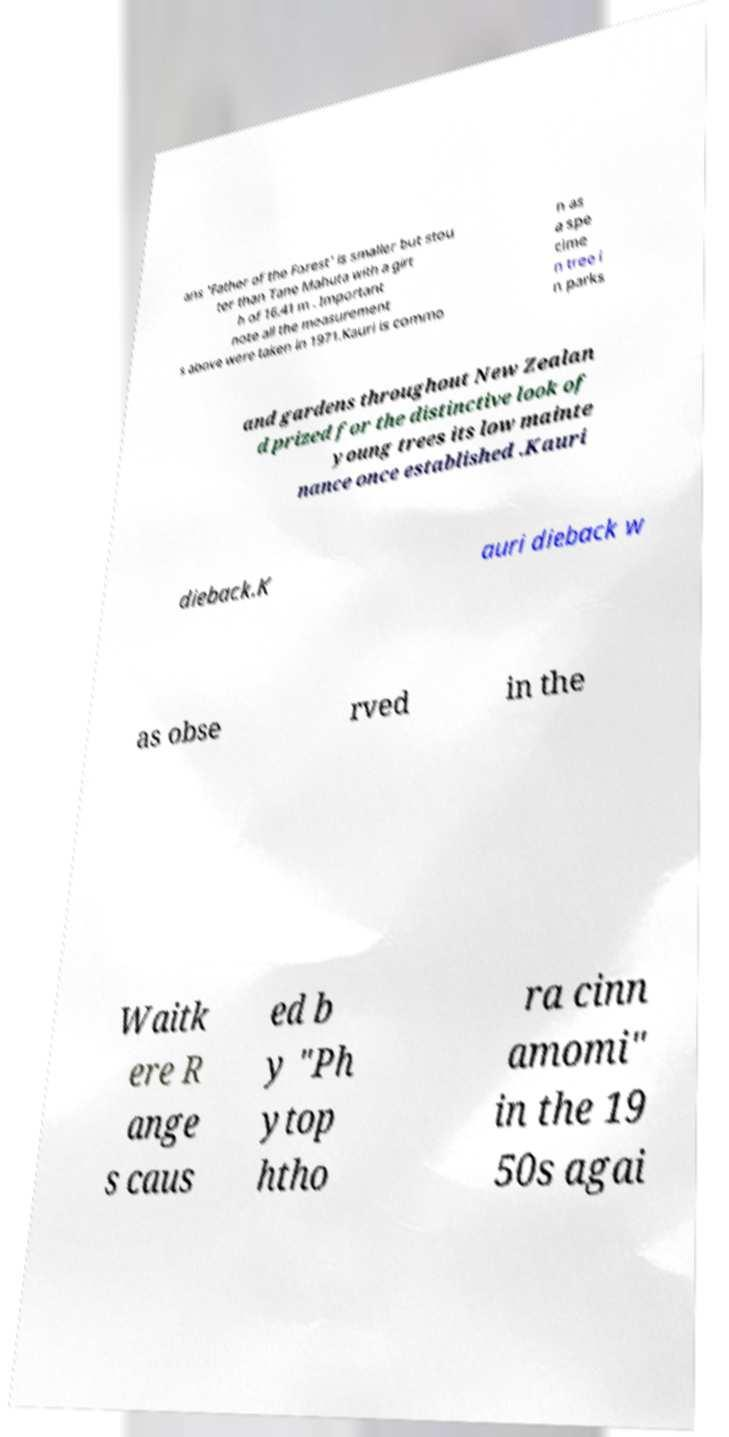Can you accurately transcribe the text from the provided image for me? ans 'Father of the Forest' is smaller but stou ter than Tane Mahuta with a girt h of 16.41 m . Important note all the measurement s above were taken in 1971.Kauri is commo n as a spe cime n tree i n parks and gardens throughout New Zealan d prized for the distinctive look of young trees its low mainte nance once established .Kauri dieback.K auri dieback w as obse rved in the Waitk ere R ange s caus ed b y "Ph ytop htho ra cinn amomi" in the 19 50s agai 